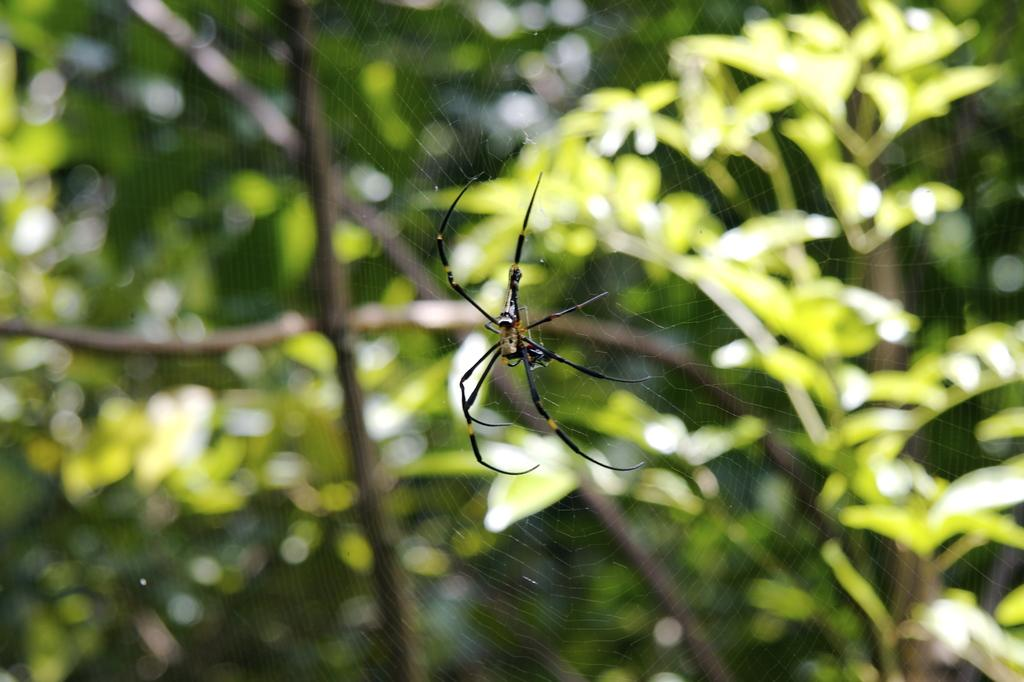What is the main subject of the image? There is a spider in the image. Where is the spider located in relation to the web? The spider is on a web. What is the position of the spider in the image? The spider is in the center of the image. What can be seen in the background of the image? There are trees in the background of the image. What type of kite can be seen flying in the middle of the image? There is no kite present in the image; it features a spider on a web. What street is visible in the background of the image? There is no street visible in the background of the image; it features trees. 